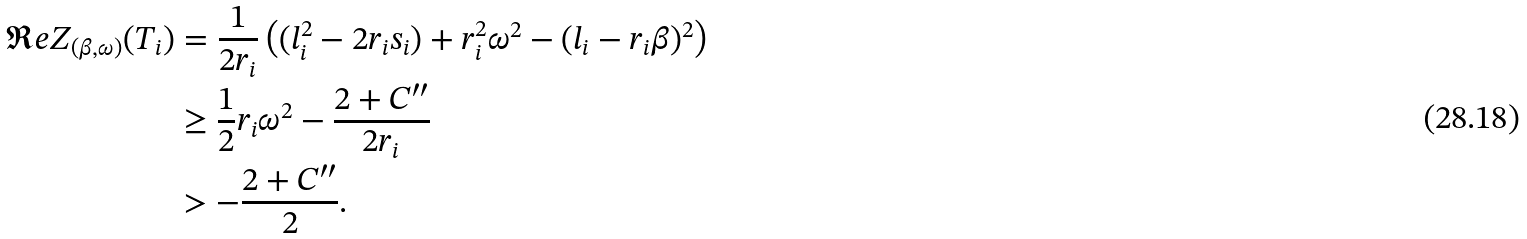Convert formula to latex. <formula><loc_0><loc_0><loc_500><loc_500>\Re e Z _ { ( \beta , \omega ) } ( T _ { i } ) & = \frac { 1 } { 2 r _ { i } } \left ( ( l _ { i } ^ { 2 } - 2 r _ { i } s _ { i } ) + r _ { i } ^ { 2 } \omega ^ { 2 } - ( l _ { i } - r _ { i } \beta ) ^ { 2 } \right ) \\ & \geq \frac { 1 } { 2 } r _ { i } \omega ^ { 2 } - \frac { 2 + C ^ { \prime \prime } } { 2 r _ { i } } \\ & > - \frac { 2 + C ^ { \prime \prime } } { 2 } .</formula> 